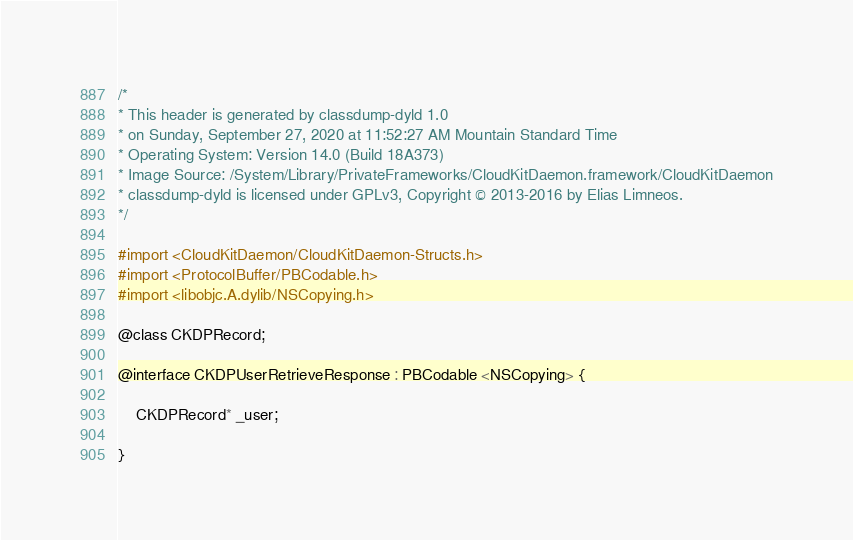<code> <loc_0><loc_0><loc_500><loc_500><_C_>/*
* This header is generated by classdump-dyld 1.0
* on Sunday, September 27, 2020 at 11:52:27 AM Mountain Standard Time
* Operating System: Version 14.0 (Build 18A373)
* Image Source: /System/Library/PrivateFrameworks/CloudKitDaemon.framework/CloudKitDaemon
* classdump-dyld is licensed under GPLv3, Copyright © 2013-2016 by Elias Limneos.
*/

#import <CloudKitDaemon/CloudKitDaemon-Structs.h>
#import <ProtocolBuffer/PBCodable.h>
#import <libobjc.A.dylib/NSCopying.h>

@class CKDPRecord;

@interface CKDPUserRetrieveResponse : PBCodable <NSCopying> {

	CKDPRecord* _user;

}
</code> 